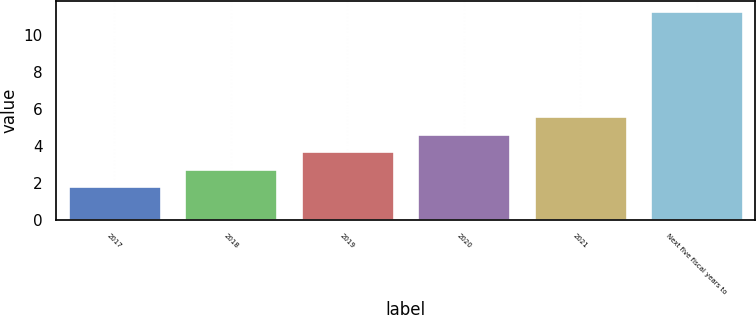<chart> <loc_0><loc_0><loc_500><loc_500><bar_chart><fcel>2017<fcel>2018<fcel>2019<fcel>2020<fcel>2021<fcel>Next five fiscal years to<nl><fcel>1.8<fcel>2.75<fcel>3.7<fcel>4.65<fcel>5.6<fcel>11.3<nl></chart> 